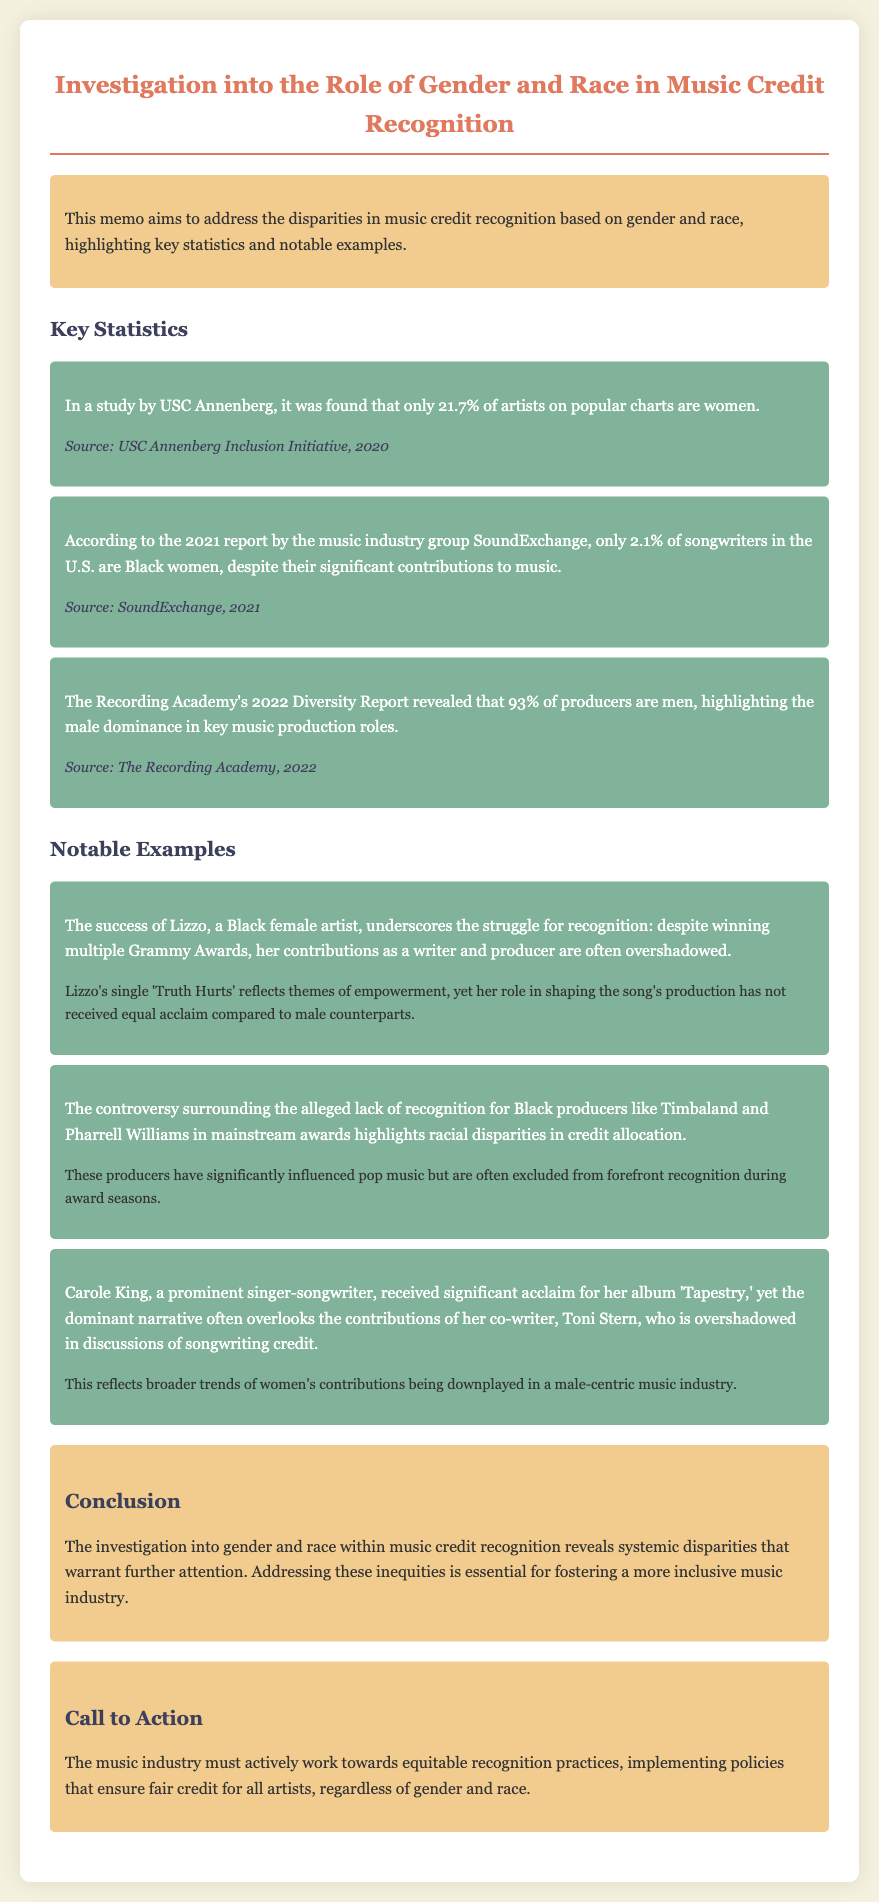What percentage of artists on popular charts are women? The statistics indicate that only 21.7% of artists on popular charts are women.
Answer: 21.7% What is the percentage of Black women songwriters in the U.S.? According to the report by SoundExchange, only 2.1% of songwriters in the U.S. are Black women.
Answer: 2.1% What percentage of producers are men, according to the Recording Academy's Diversity Report? The report reveals that 93% of producers are men.
Answer: 93% Which artist is mentioned as having won multiple Grammy Awards? Lizzo is highlighted as a Black female artist who has won multiple Grammy Awards.
Answer: Lizzo What significant contribution is often overlooked regarding Lizzo? Despite her success, her contributions as a writer and producer are often overshadowed.
Answer: Writing and producing Which two producers are noted for their influence but lack recognition? Timbaland and Pharrell Williams are mentioned in connection to the controversy over recognition.
Answer: Timbaland and Pharrell Williams What album is Carole King famous for? Carole King received significant acclaim for her album 'Tapestry.'
Answer: 'Tapestry' What action does the memo call for in the music industry? The call to action emphasizes the need for equitable recognition practices in the music industry.
Answer: Equitable recognition practices What theme does Lizzo's single 'Truth Hurts' reflect? The themes of empowerment are highlighted in connection with Lizzo's single.
Answer: Empowerment 